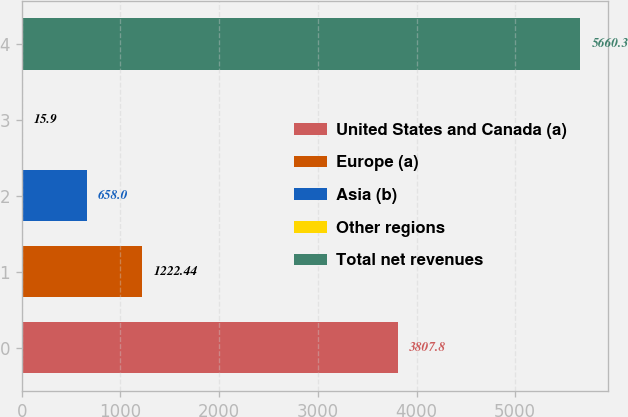Convert chart. <chart><loc_0><loc_0><loc_500><loc_500><bar_chart><fcel>United States and Canada (a)<fcel>Europe (a)<fcel>Asia (b)<fcel>Other regions<fcel>Total net revenues<nl><fcel>3807.8<fcel>1222.44<fcel>658<fcel>15.9<fcel>5660.3<nl></chart> 